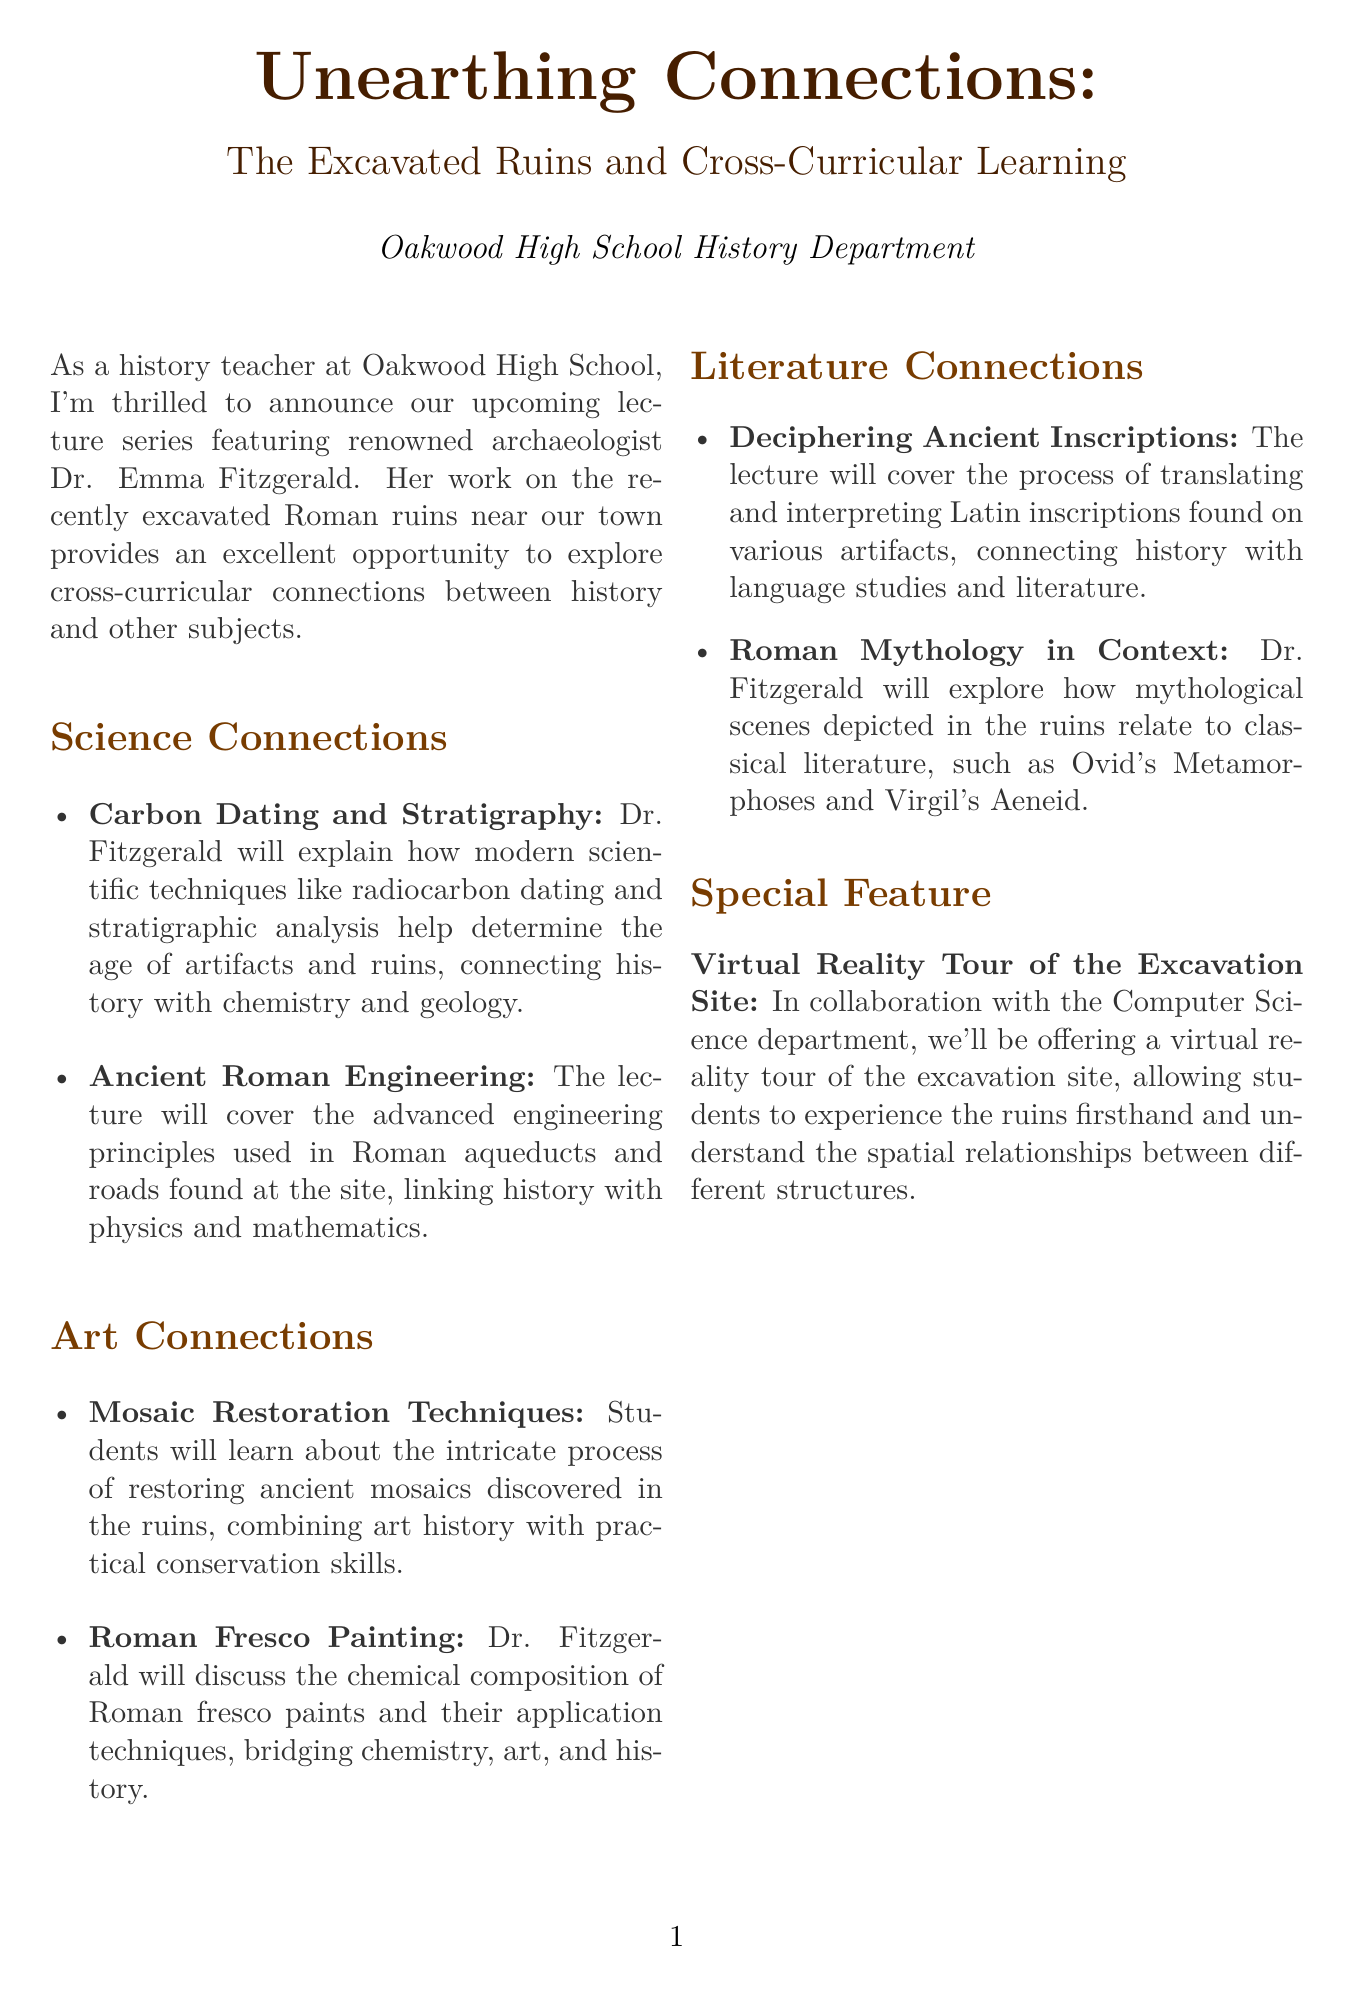What is the title of the newsletter? The title is stated prominently at the beginning of the document.
Answer: Unearthing Connections: The Excavated Ruins and Cross-Curricular Learning Who is the featured archaeologist? The document identifies the main speaker of the lecture series.
Answer: Dr. Emma Fitzgerald What day of the week will the lectures take place? The document specifies the day the lectures are scheduled.
Answer: Thursday What is one of the science connections highlighted in the document? The document lists specific connections between history and other subjects in distinct categories.
Answer: Carbon Dating and Stratigraphy What is the special feature mentioned in the newsletter? The document describes a specific addition to the lecture series that enhances the experience.
Answer: Virtual Reality Tour of the Excavation Site Which two literary works are connected to Roman mythology in the document? The document mentions specific classical literature as part of the literature connections.
Answer: Ovid's Metamorphoses and Virgil's Aeneid What time do the lectures start? The document includes the scheduled starting time for the lectures.
Answer: 4 PM How many areas of cross-curricular connections are discussed in the document? Counting the sections provides an overview of the topics covered.
Answer: Three 